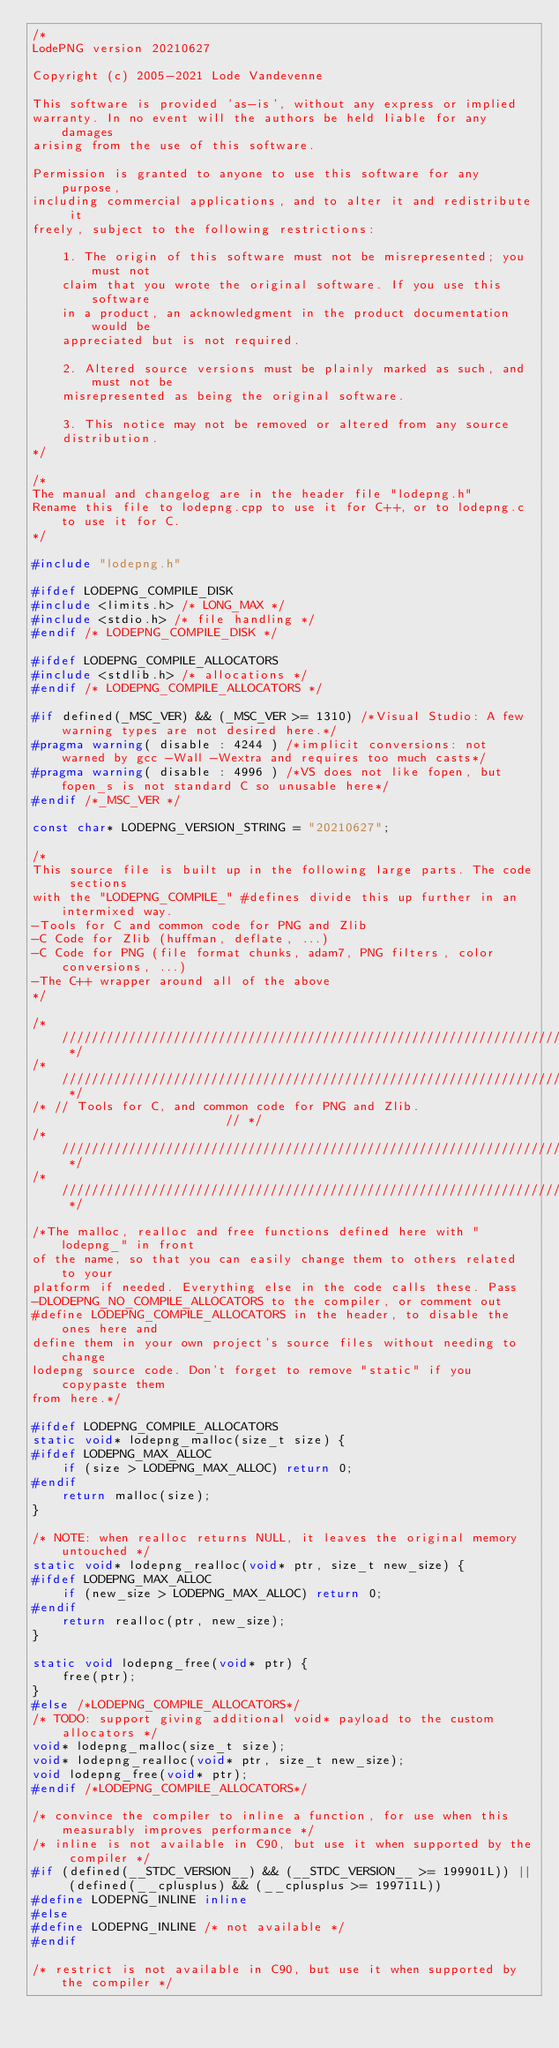<code> <loc_0><loc_0><loc_500><loc_500><_C++_>/*
LodePNG version 20210627

Copyright (c) 2005-2021 Lode Vandevenne

This software is provided 'as-is', without any express or implied
warranty. In no event will the authors be held liable for any damages
arising from the use of this software.

Permission is granted to anyone to use this software for any purpose,
including commercial applications, and to alter it and redistribute it
freely, subject to the following restrictions:

    1. The origin of this software must not be misrepresented; you must not
    claim that you wrote the original software. If you use this software
    in a product, an acknowledgment in the product documentation would be
    appreciated but is not required.

    2. Altered source versions must be plainly marked as such, and must not be
    misrepresented as being the original software.

    3. This notice may not be removed or altered from any source
    distribution.
*/

/*
The manual and changelog are in the header file "lodepng.h"
Rename this file to lodepng.cpp to use it for C++, or to lodepng.c to use it for C.
*/

#include "lodepng.h"

#ifdef LODEPNG_COMPILE_DISK
#include <limits.h> /* LONG_MAX */
#include <stdio.h> /* file handling */
#endif /* LODEPNG_COMPILE_DISK */

#ifdef LODEPNG_COMPILE_ALLOCATORS
#include <stdlib.h> /* allocations */
#endif /* LODEPNG_COMPILE_ALLOCATORS */

#if defined(_MSC_VER) && (_MSC_VER >= 1310) /*Visual Studio: A few warning types are not desired here.*/
#pragma warning( disable : 4244 ) /*implicit conversions: not warned by gcc -Wall -Wextra and requires too much casts*/
#pragma warning( disable : 4996 ) /*VS does not like fopen, but fopen_s is not standard C so unusable here*/
#endif /*_MSC_VER */

const char* LODEPNG_VERSION_STRING = "20210627";

/*
This source file is built up in the following large parts. The code sections
with the "LODEPNG_COMPILE_" #defines divide this up further in an intermixed way.
-Tools for C and common code for PNG and Zlib
-C Code for Zlib (huffman, deflate, ...)
-C Code for PNG (file format chunks, adam7, PNG filters, color conversions, ...)
-The C++ wrapper around all of the above
*/

/* ////////////////////////////////////////////////////////////////////////// */
/* ////////////////////////////////////////////////////////////////////////// */
/* // Tools for C, and common code for PNG and Zlib.                       // */
/* ////////////////////////////////////////////////////////////////////////// */
/* ////////////////////////////////////////////////////////////////////////// */

/*The malloc, realloc and free functions defined here with "lodepng_" in front
of the name, so that you can easily change them to others related to your
platform if needed. Everything else in the code calls these. Pass
-DLODEPNG_NO_COMPILE_ALLOCATORS to the compiler, or comment out
#define LODEPNG_COMPILE_ALLOCATORS in the header, to disable the ones here and
define them in your own project's source files without needing to change
lodepng source code. Don't forget to remove "static" if you copypaste them
from here.*/

#ifdef LODEPNG_COMPILE_ALLOCATORS
static void* lodepng_malloc(size_t size) {
#ifdef LODEPNG_MAX_ALLOC
    if (size > LODEPNG_MAX_ALLOC) return 0;
#endif
    return malloc(size);
}

/* NOTE: when realloc returns NULL, it leaves the original memory untouched */
static void* lodepng_realloc(void* ptr, size_t new_size) {
#ifdef LODEPNG_MAX_ALLOC
    if (new_size > LODEPNG_MAX_ALLOC) return 0;
#endif
    return realloc(ptr, new_size);
}

static void lodepng_free(void* ptr) {
    free(ptr);
}
#else /*LODEPNG_COMPILE_ALLOCATORS*/
/* TODO: support giving additional void* payload to the custom allocators */
void* lodepng_malloc(size_t size);
void* lodepng_realloc(void* ptr, size_t new_size);
void lodepng_free(void* ptr);
#endif /*LODEPNG_COMPILE_ALLOCATORS*/

/* convince the compiler to inline a function, for use when this measurably improves performance */
/* inline is not available in C90, but use it when supported by the compiler */
#if (defined(__STDC_VERSION__) && (__STDC_VERSION__ >= 199901L)) || (defined(__cplusplus) && (__cplusplus >= 199711L))
#define LODEPNG_INLINE inline
#else
#define LODEPNG_INLINE /* not available */
#endif

/* restrict is not available in C90, but use it when supported by the compiler */</code> 